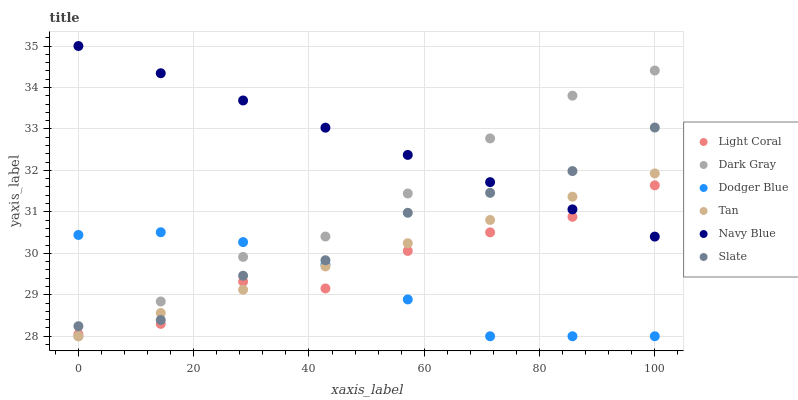Does Dodger Blue have the minimum area under the curve?
Answer yes or no. Yes. Does Navy Blue have the maximum area under the curve?
Answer yes or no. Yes. Does Slate have the minimum area under the curve?
Answer yes or no. No. Does Slate have the maximum area under the curve?
Answer yes or no. No. Is Tan the smoothest?
Answer yes or no. Yes. Is Light Coral the roughest?
Answer yes or no. Yes. Is Navy Blue the smoothest?
Answer yes or no. No. Is Navy Blue the roughest?
Answer yes or no. No. Does Dark Gray have the lowest value?
Answer yes or no. Yes. Does Slate have the lowest value?
Answer yes or no. No. Does Navy Blue have the highest value?
Answer yes or no. Yes. Does Slate have the highest value?
Answer yes or no. No. Is Light Coral less than Slate?
Answer yes or no. Yes. Is Navy Blue greater than Dodger Blue?
Answer yes or no. Yes. Does Dark Gray intersect Slate?
Answer yes or no. Yes. Is Dark Gray less than Slate?
Answer yes or no. No. Is Dark Gray greater than Slate?
Answer yes or no. No. Does Light Coral intersect Slate?
Answer yes or no. No. 